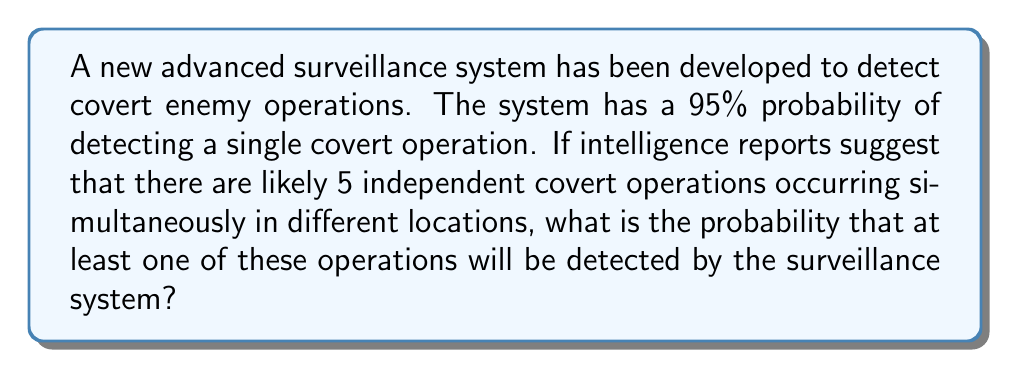Solve this math problem. Let's approach this step-by-step:

1) First, let's define our events:
   Let A be the event of detecting a single covert operation.
   P(A) = 0.95

2) We want to find the probability of detecting at least one out of 5 operations. It's easier to calculate the complement of this event - the probability of detecting none of the 5 operations.

3) For a single operation, the probability of not detecting it is:
   P(not A) = 1 - P(A) = 1 - 0.95 = 0.05

4) Since the operations are independent, the probability of not detecting any of the 5 operations is:
   P(detecting none) = $(0.05)^5$

5) Therefore, the probability of detecting at least one operation is:
   P(detecting at least one) = 1 - P(detecting none)
                              = $1 - (0.05)^5$

6) Let's calculate this:
   $1 - (0.05)^5 = 1 - 3.125 \times 10^{-7} = 0.9999996875$

7) Converting to a percentage:
   0.9999996875 * 100% ≈ 99.999969%
Answer: 99.999969% 